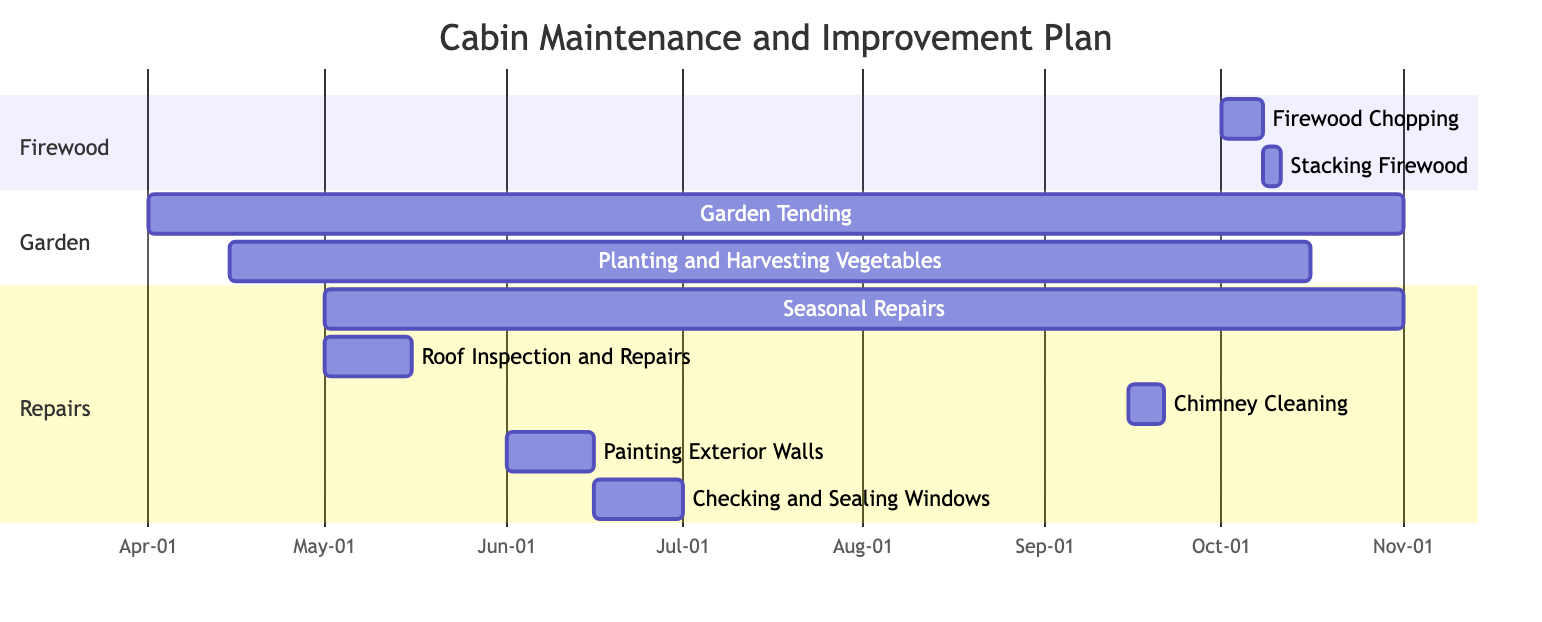What is the duration of the Firewood Chopping task? The Firewood Chopping task starts on October 1, 2023, and ends on October 7, 2023. Therefore, the duration is calculated as October 7 minus October 1, which equals 7 days.
Answer: 7 days Which task starts immediately after Firewood Chopping? According to the dependencies shown in the diagram, Stacking Firewood depends on Firewood Chopping. Stacking Firewood starts on October 8, which is immediately after the end of Firewood Chopping on October 7.
Answer: Stacking Firewood How many tasks overlap during the month of June 2023? In June 2023, there are three tasks: Painting Exterior Walls (June 1-15), Checking and Sealing Windows (June 16-30). When examining their start and end dates, both tasks occur in the same month, but do not overlap in actual dates. Thus, the total number of overlapping tasks during June is 0.
Answer: 0 What is the total duration of the Seasonal Repairs task? The Seasonal Repairs task begins on May 1, 2023, and lasts until October 31, 2023. To find the total duration, we calculate October 31 minus May 1, resulting in a duration of 184 days.
Answer: 184 days Which task finishes last in this maintenance plan? By examining the end dates of all tasks, the task that finishes the latest is Garden Tending, which ends on October 31, 2023.
Answer: Garden Tending 